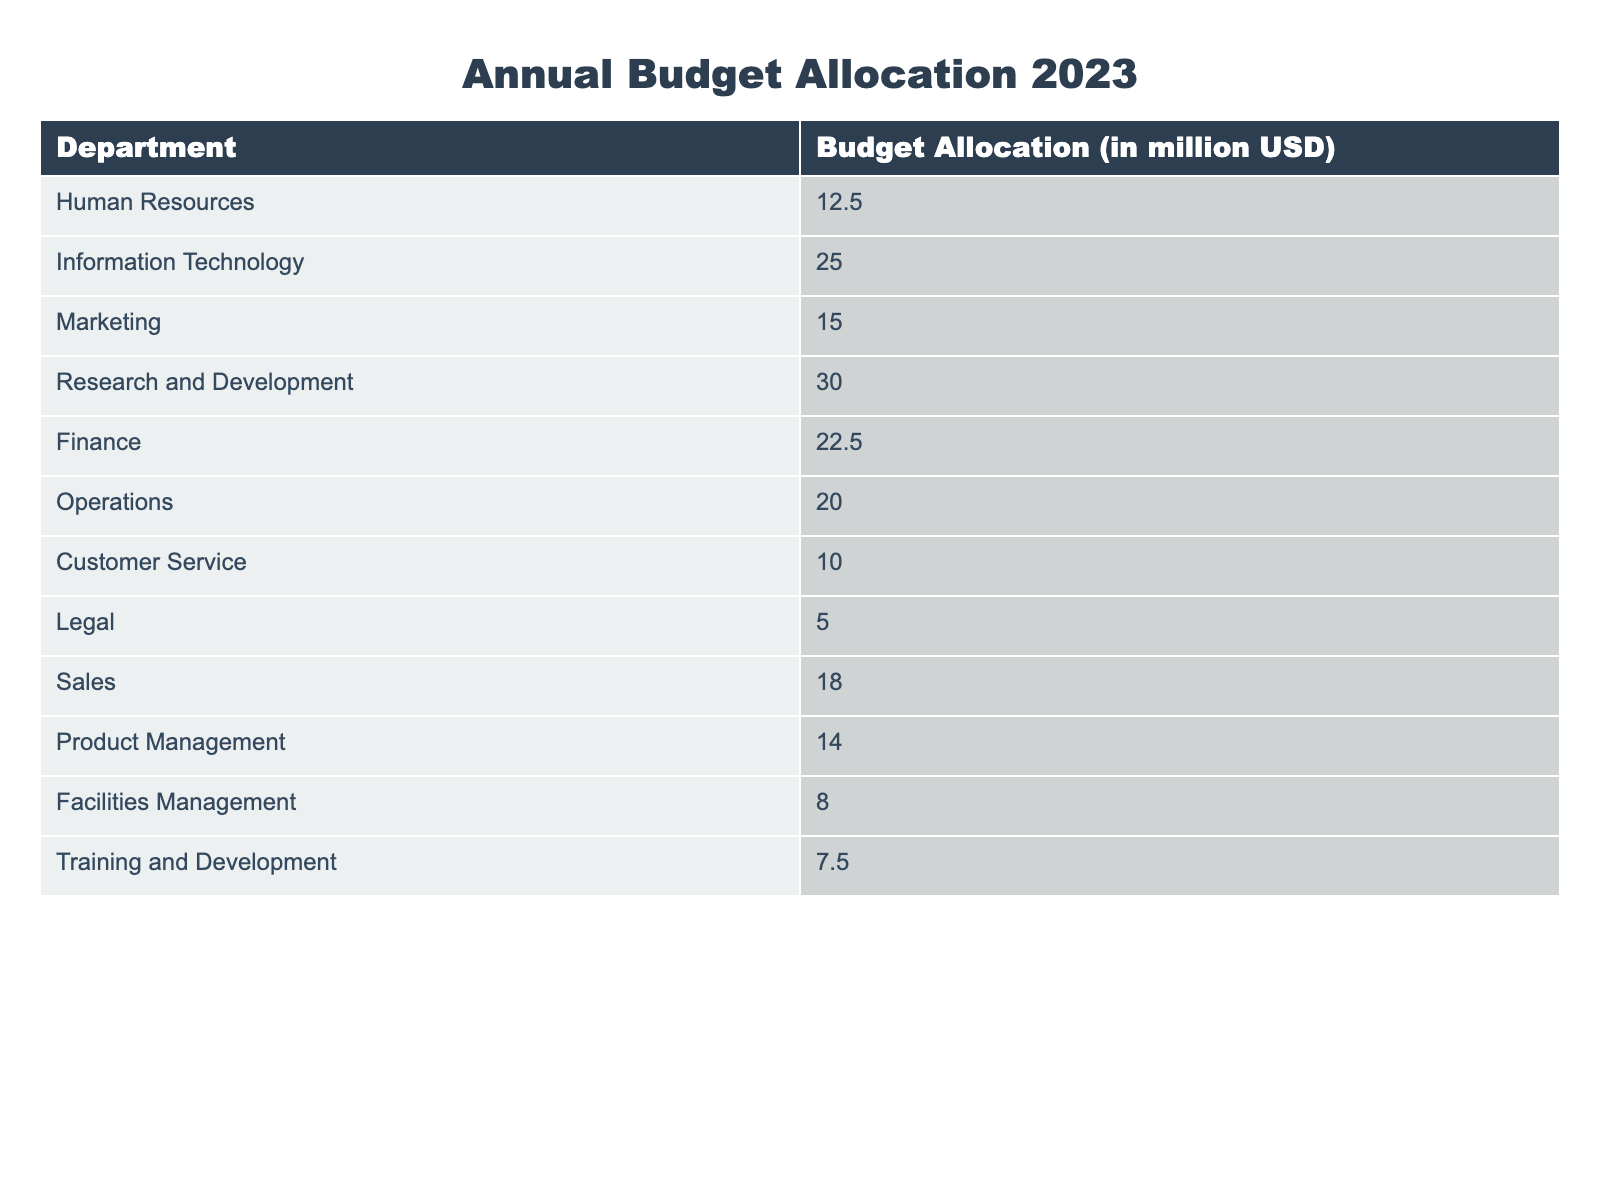What is the total budget allocation for the Marketing and Sales departments? The budget allocation for Marketing is 15 million USD and for Sales it is 18 million USD. Adding these two amounts together gives us 15 + 18 = 33 million USD.
Answer: 33 million USD Which department has the highest budget allocation? By comparing the budget allocations listed, Research and Development has the highest allocation at 30 million USD. It's higher than the allocation for any other department.
Answer: Research and Development Is the budget allocation for Customer Service greater than that for Facilities Management? The budget allocation for Customer Service is 10 million USD, while for Facilities Management it is 8 million USD. Since 10 is greater than 8, the statement is true.
Answer: Yes What is the average budget allocation across all departments? To find the average, we need to sum all the budget allocations: 12.5 + 25 + 15 + 30 + 22.5 + 20 + 10 + 5 + 18 + 14 + 8 + 7.5 =  2.5 million USD. There are 12 departments, so we divide the total by 12, which gives us 2.5 / 12 = approximately 17.5 million USD.
Answer: 17.5 million USD What is the difference in budget allocation between the Information Technology and Legal departments? The budget allocation for Information Technology is 25 million USD and for Legal, it is 5 million USD. The difference is calculated as 25 - 5 = 20 million USD.
Answer: 20 million USD How much more budget is allocated to Human Resources than to Training and Development? Human Resources has a budget allocation of 12.5 million USD and Training and Development has an allocation of 7.5 million USD. The difference is 12.5 - 7.5 = 5 million USD.
Answer: 5 million USD If we combine the budgets for Operations and Finance, what is the total? The budget for Operations is 20 million USD and for Finance, it is 22.5 million USD. Combining these amounts gives us 20 + 22.5 = 42.5 million USD.
Answer: 42.5 million USD Are there any departments that have an allocation of exactly 10 million USD? Yes, looking at the table, the budget allocation for Customer Service is exactly 10 million USD. Therefore, the statement is true.
Answer: Yes What percentage of the total budget does the Legal department's allocation represent? The total budget allocation is 12.5 + 25 + 15 + 30 + 22.5 + 20 + 10 + 5 + 18 + 14 + 8 + 7.5 =  12.5 million USD. To find the percentage for Legal, we have (5 / total) * 100. After calculating the total is 12.5 million USD, the percentage is (5 /  12.5) * 100 = 40%.
Answer: 40% 